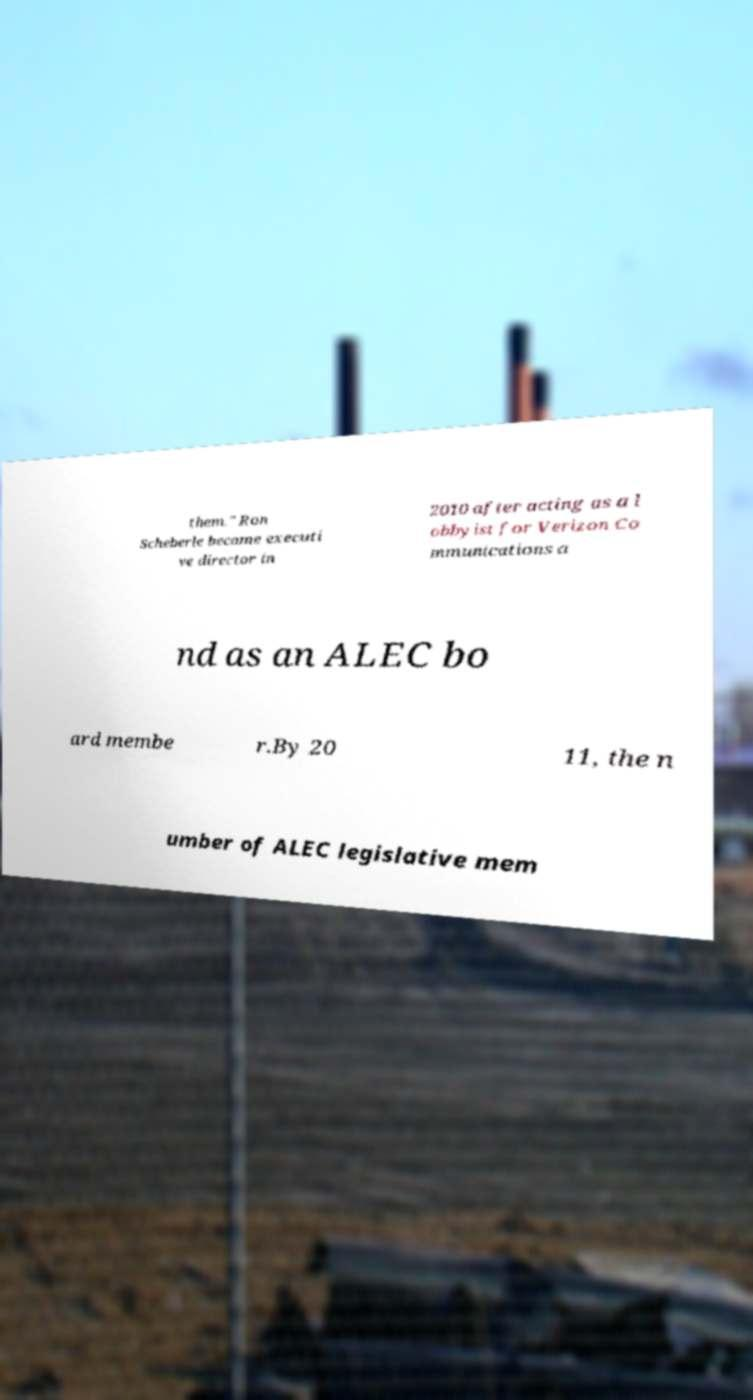I need the written content from this picture converted into text. Can you do that? them." Ron Scheberle became executi ve director in 2010 after acting as a l obbyist for Verizon Co mmunications a nd as an ALEC bo ard membe r.By 20 11, the n umber of ALEC legislative mem 